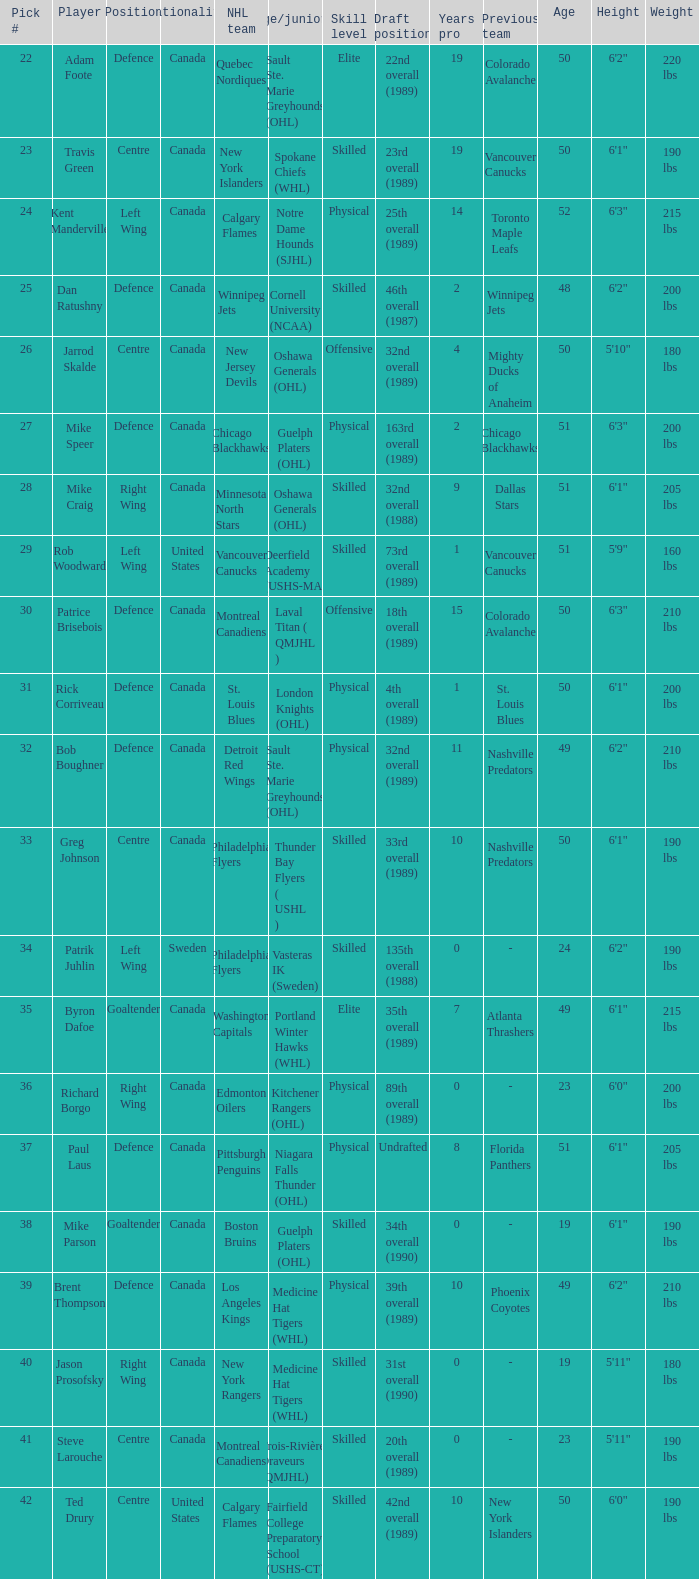What is the country of origin for the player chosen to join the washington capitals? Canada. 